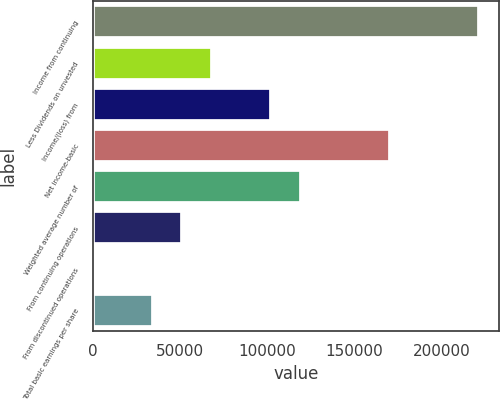Convert chart to OTSL. <chart><loc_0><loc_0><loc_500><loc_500><bar_chart><fcel>Income from continuing<fcel>Less Dividends on unvested<fcel>Income/(loss) from<fcel>Net income-basic<fcel>Weighted average number of<fcel>From continuing operations<fcel>From discontinued operations<fcel>Total basic earnings per share<nl><fcel>221835<fcel>68256.8<fcel>102385<fcel>170642<fcel>119449<fcel>51192.6<fcel>0.01<fcel>34128.4<nl></chart> 